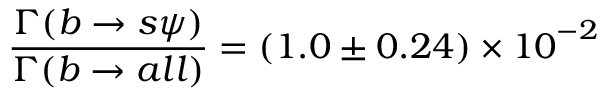Convert formula to latex. <formula><loc_0><loc_0><loc_500><loc_500>\frac { \Gamma ( b \rightarrow s \psi ) } { \Gamma ( b \rightarrow a l l ) } = ( 1 . 0 \pm 0 . 2 4 ) \times { 1 0 } ^ { - 2 }</formula> 